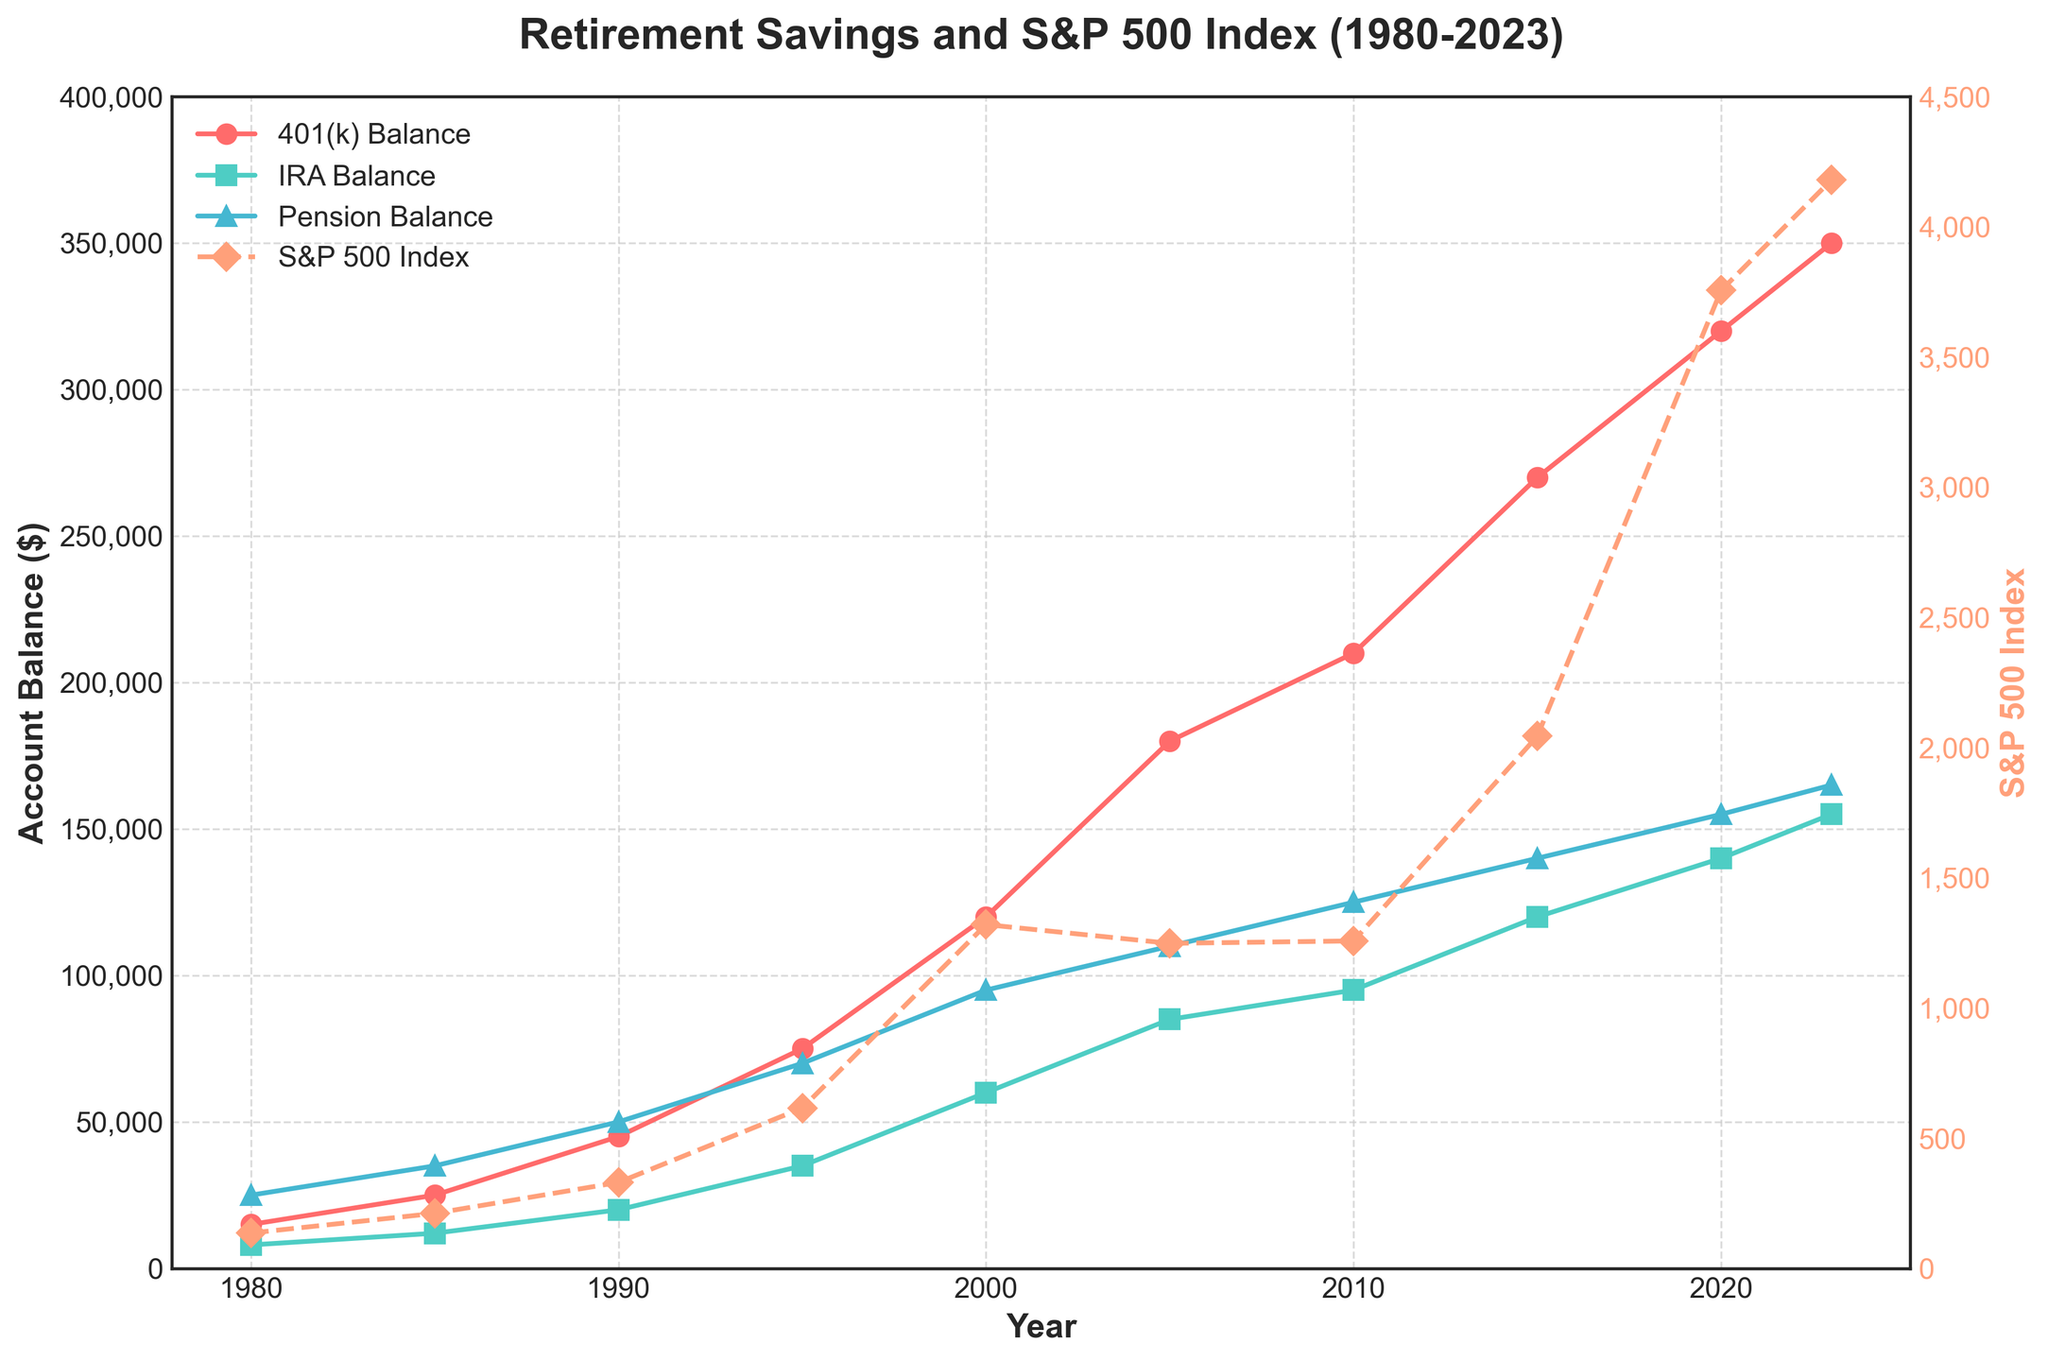Which year had the highest average 401(k) balance? To find the highest average 401(k) balance, look for the highest point on the red line in the plot. The year corresponding to this point will be the answer.
Answer: 2023 Which account balance had the smallest value in 1980? Look at the plot's markers corresponding to the year 1980 and identify the smallest value. Compare the markers of the 401(k), IRA, and Pension balances.
Answer: IRA Balance What is the difference between the 401(k) balance and the IRA balance in 2020? Find the points on the 401(k) and IRA lines for the year 2020. Subtract the IRA balance from the 401(k) balance.
Answer: 180,000 (320,000 - 140,000) How did the S&P 500 Index change from 1980 to 2000? Observe the orange dashed line representing the S&P 500 Index. Note the values at 1980 and 2000 and calculate the difference. The index increased.
Answer: Increased by 1,184.52 (1,320.28 - 135.76) Compare the IRA and Pension balances in 2015. Which one is higher? Look at the markers for the year 2015 on both the green and blue lines. The higher one corresponds to the account balance that is larger.
Answer: Pension Balance What's the combined value of average 401(k) and IRA balances in 1995? Find the respective values for the 401(k) and IRA balances in 1995 and sum them up.
Answer: 110,000 (75,000 + 35,000) In which year did the average Pension balance first exceed 100,000? Check the blue line for the first point where the value exceeds 100,000. The corresponding year is the answer.
Answer: 2010 What was the trend of 401(k) balances from 1980 to 2023? Observe the red line across the years and describe the overall movement—whether it is increasing, decreasing, or stable.
Answer: Increasing trend By how much did the average IRA balance increase from 2000 to 2023? Identify the values of the IRA balance in 2000 and 2023, then calculate the increase by subtracting the 2000 value from the 2023 value.
Answer: 95,000 (155,000 - 60,000) Which year saw the largest increase in the S&P 500 Index? Identify the years where the slope of the orange dashed line is the steepest, indicating the largest increase.
Answer: 2020-2023 